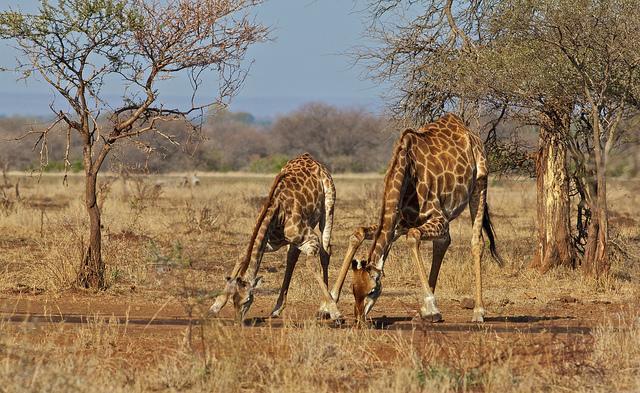How many giraffes are visible?
Give a very brief answer. 2. 